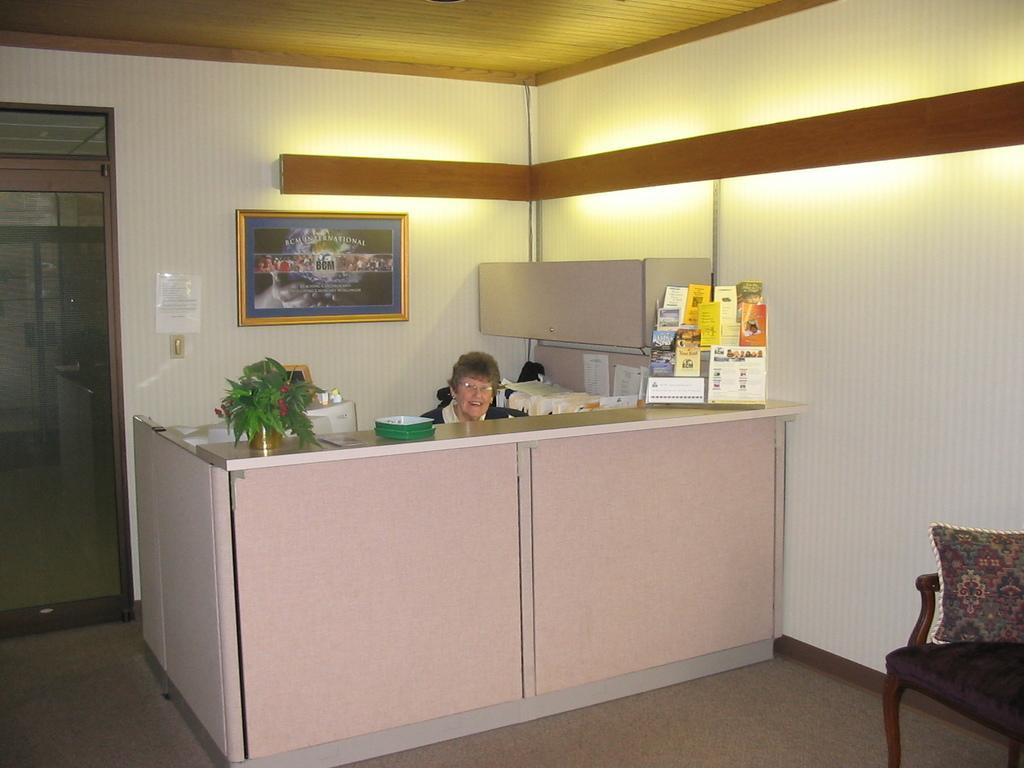Can you describe this image briefly? In this picture there is a woman sitting in chair , and there are books, table , plant , frame attached to wall , door, couch , pillow. 